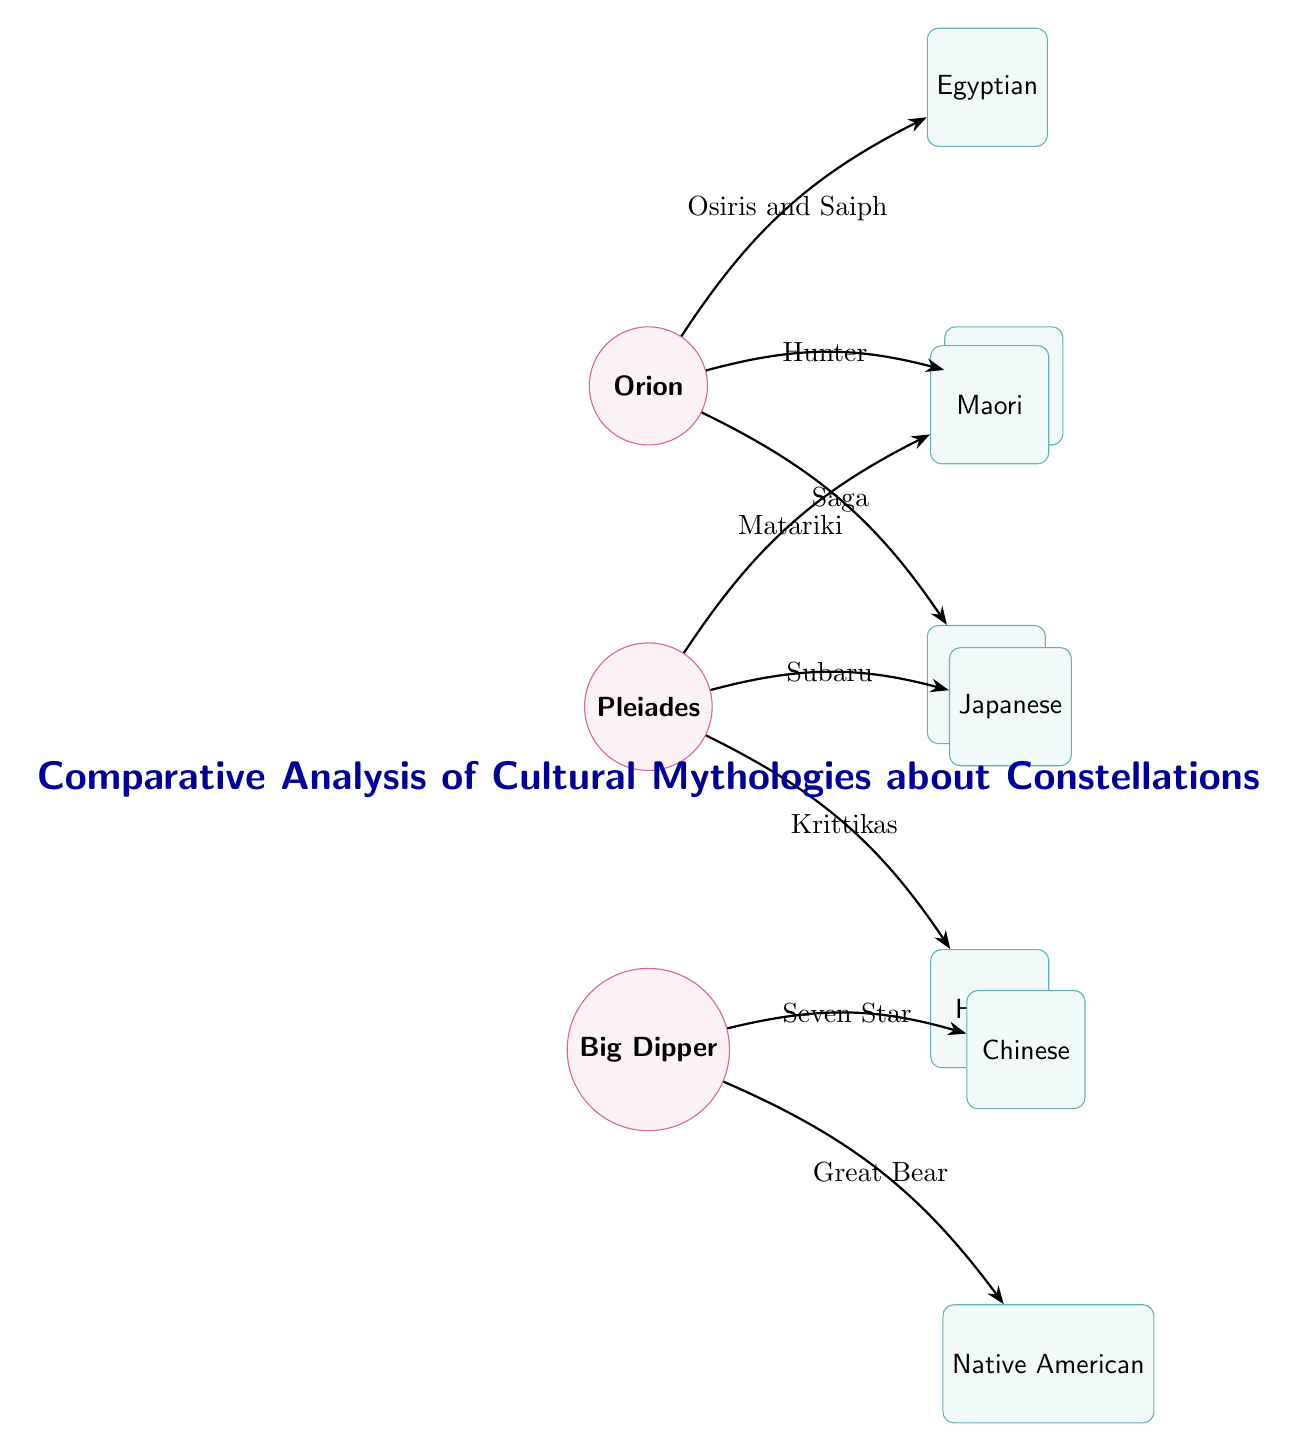What mythology is associated with Orion? Orion is connected to three mythologies in the diagram. The connection to Greek mythology is labeled "Hunter," indicating that Orion is recognized as a hunter in this cultural context.
Answer: Greek How many constellations are depicted in the diagram? There are three constellations shown: Orion, Pleiades, and Big Dipper. By counting each node labeled as "constellation," we conclude there are three.
Answer: 3 What is the Japanese name for the Pleiades? The connection from Pleiades to Japanese mythology is labeled "Subaru." This directly indicates that in Japanese culture, the Pleiades constellation is known as Subaru.
Answer: Subaru Which mythology relates to the Big Dipper as "Seven Star"? The Big Dipper connects to Chinese mythology with the label "Seven Star." By following this edge, we identify the associated mythology as Chinese.
Answer: Chinese What is the relationship between Pleiades and Maori mythology? The edge connecting Pleiades to Maori mythology is labeled "Matariki." This shows that in Maori culture, Pleiades is known through this term.
Answer: Matariki Which mythology describes Orion as Osiris and Saiph? The relationship labeled "Osiris and Saiph" connects Orion to Egyptian mythology. This indicates that in Egyptian culture, Orion is associated with these figures.
Answer: Egyptian How many mythologies link to the Pleiades constellation? The Pleiades are connected to three distinct mythologies: Japanese, Maori, and Hindu. Each edge represents a separate mythology which confirms the number is three.
Answer: 3 Which mythology refers to Big Dipper as "Great Bear"? The connection from Big Dipper to Native American mythology is labeled "Great Bear," indicating how this culture represents the constellation.
Answer: Native American 